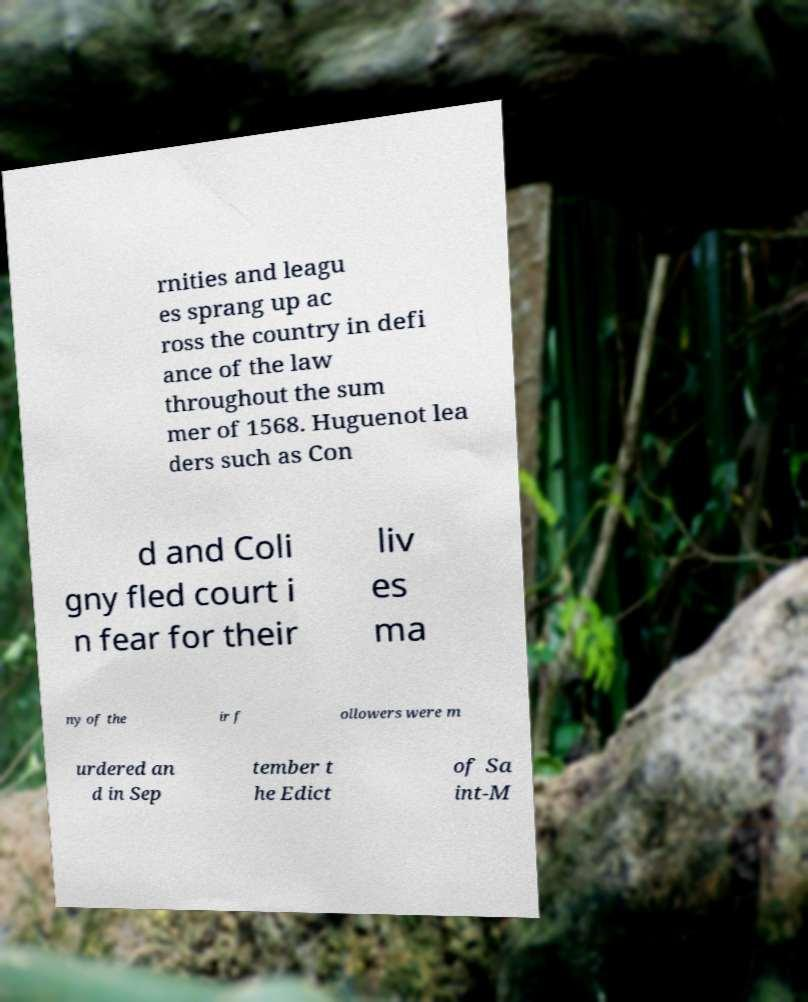Can you accurately transcribe the text from the provided image for me? rnities and leagu es sprang up ac ross the country in defi ance of the law throughout the sum mer of 1568. Huguenot lea ders such as Con d and Coli gny fled court i n fear for their liv es ma ny of the ir f ollowers were m urdered an d in Sep tember t he Edict of Sa int-M 